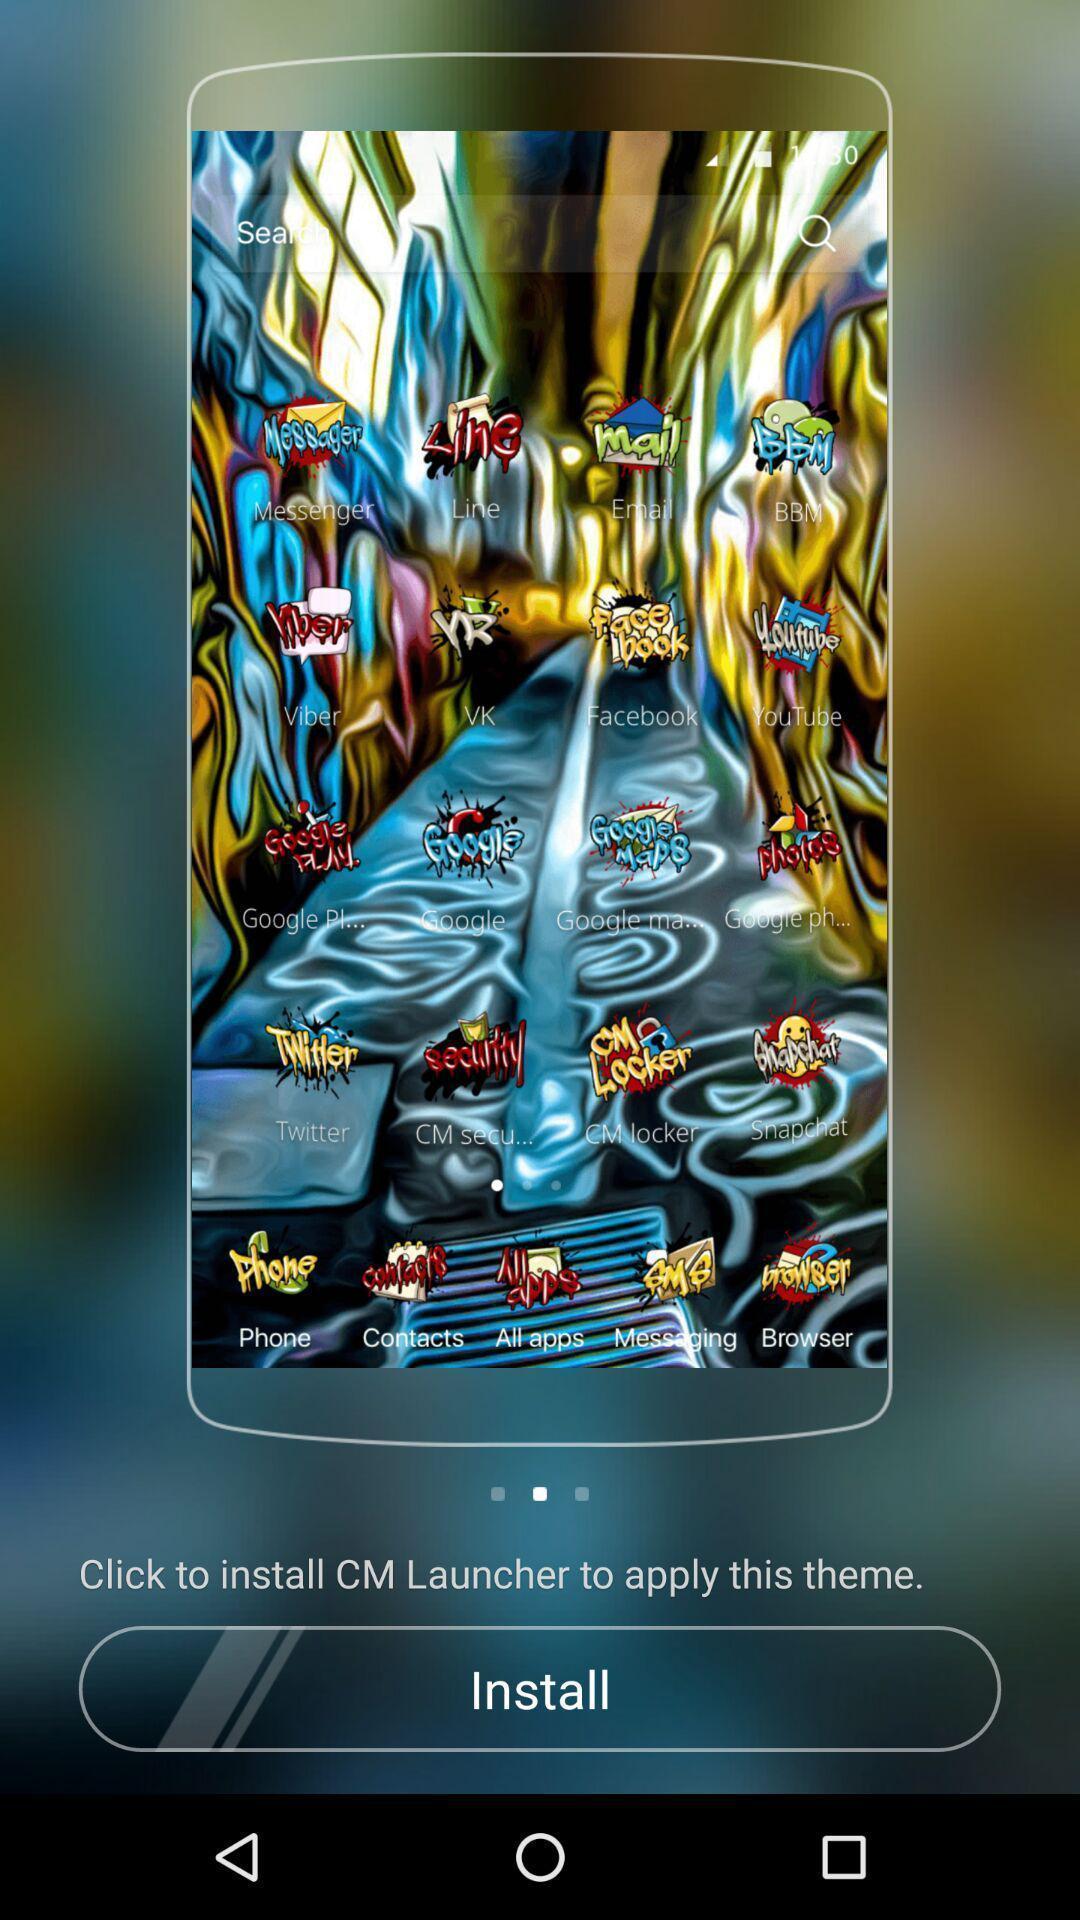What can you discern from this picture? Text stickers page in the phone. 